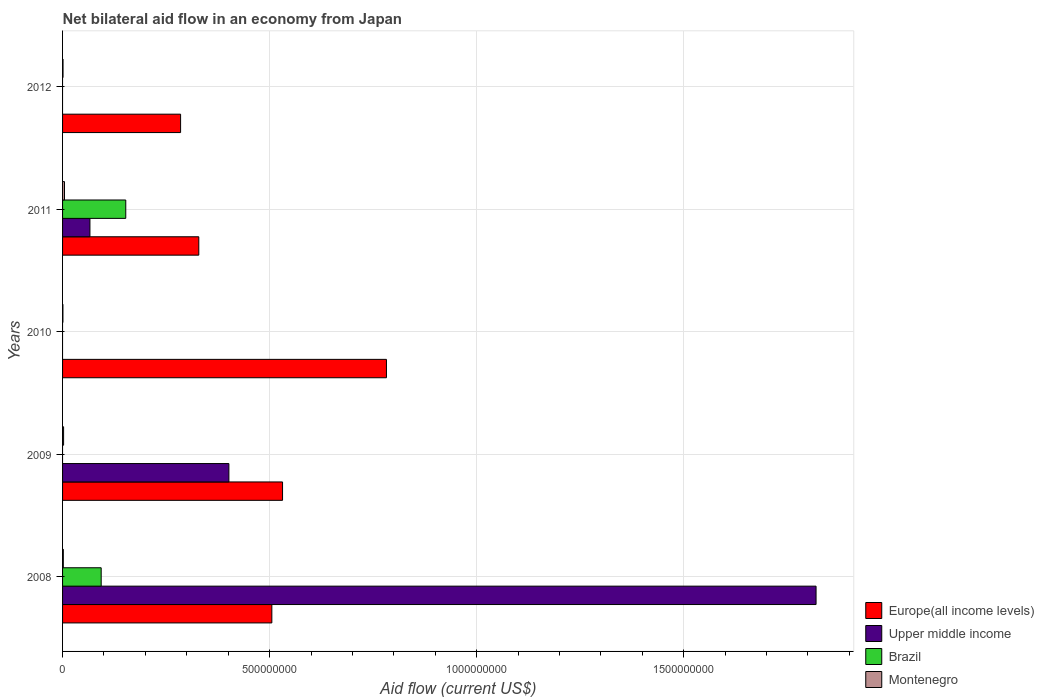How many different coloured bars are there?
Offer a terse response. 4. How many groups of bars are there?
Your response must be concise. 5. Are the number of bars on each tick of the Y-axis equal?
Your answer should be very brief. No. How many bars are there on the 5th tick from the top?
Your answer should be compact. 4. How many bars are there on the 4th tick from the bottom?
Your response must be concise. 4. In how many cases, is the number of bars for a given year not equal to the number of legend labels?
Ensure brevity in your answer.  3. What is the net bilateral aid flow in Brazil in 2012?
Keep it short and to the point. 0. Across all years, what is the maximum net bilateral aid flow in Montenegro?
Make the answer very short. 4.67e+06. Across all years, what is the minimum net bilateral aid flow in Europe(all income levels)?
Offer a terse response. 2.85e+08. In which year was the net bilateral aid flow in Upper middle income maximum?
Your response must be concise. 2008. What is the total net bilateral aid flow in Brazil in the graph?
Your answer should be very brief. 2.46e+08. What is the difference between the net bilateral aid flow in Montenegro in 2009 and that in 2010?
Your answer should be compact. 1.63e+06. What is the difference between the net bilateral aid flow in Brazil in 2010 and the net bilateral aid flow in Europe(all income levels) in 2009?
Your answer should be very brief. -5.31e+08. What is the average net bilateral aid flow in Upper middle income per year?
Provide a short and direct response. 4.58e+08. In the year 2012, what is the difference between the net bilateral aid flow in Montenegro and net bilateral aid flow in Europe(all income levels)?
Offer a terse response. -2.84e+08. What is the ratio of the net bilateral aid flow in Montenegro in 2011 to that in 2012?
Keep it short and to the point. 4.1. Is the difference between the net bilateral aid flow in Montenegro in 2008 and 2009 greater than the difference between the net bilateral aid flow in Europe(all income levels) in 2008 and 2009?
Provide a short and direct response. Yes. What is the difference between the highest and the second highest net bilateral aid flow in Montenegro?
Provide a succinct answer. 2.17e+06. What is the difference between the highest and the lowest net bilateral aid flow in Montenegro?
Your answer should be very brief. 3.80e+06. In how many years, is the net bilateral aid flow in Brazil greater than the average net bilateral aid flow in Brazil taken over all years?
Your response must be concise. 2. Is it the case that in every year, the sum of the net bilateral aid flow in Brazil and net bilateral aid flow in Montenegro is greater than the sum of net bilateral aid flow in Europe(all income levels) and net bilateral aid flow in Upper middle income?
Make the answer very short. No. How many bars are there?
Your answer should be very brief. 15. Are all the bars in the graph horizontal?
Your response must be concise. Yes. What is the difference between two consecutive major ticks on the X-axis?
Your response must be concise. 5.00e+08. Are the values on the major ticks of X-axis written in scientific E-notation?
Provide a succinct answer. No. Does the graph contain any zero values?
Ensure brevity in your answer.  Yes. Where does the legend appear in the graph?
Offer a terse response. Bottom right. How many legend labels are there?
Provide a succinct answer. 4. How are the legend labels stacked?
Your response must be concise. Vertical. What is the title of the graph?
Give a very brief answer. Net bilateral aid flow in an economy from Japan. What is the label or title of the X-axis?
Provide a short and direct response. Aid flow (current US$). What is the label or title of the Y-axis?
Keep it short and to the point. Years. What is the Aid flow (current US$) of Europe(all income levels) in 2008?
Provide a succinct answer. 5.05e+08. What is the Aid flow (current US$) in Upper middle income in 2008?
Provide a short and direct response. 1.82e+09. What is the Aid flow (current US$) in Brazil in 2008?
Your response must be concise. 9.33e+07. What is the Aid flow (current US$) of Montenegro in 2008?
Offer a terse response. 1.85e+06. What is the Aid flow (current US$) of Europe(all income levels) in 2009?
Give a very brief answer. 5.31e+08. What is the Aid flow (current US$) of Upper middle income in 2009?
Offer a very short reply. 4.02e+08. What is the Aid flow (current US$) of Brazil in 2009?
Your answer should be compact. 0. What is the Aid flow (current US$) in Montenegro in 2009?
Your answer should be compact. 2.50e+06. What is the Aid flow (current US$) in Europe(all income levels) in 2010?
Keep it short and to the point. 7.82e+08. What is the Aid flow (current US$) in Montenegro in 2010?
Keep it short and to the point. 8.70e+05. What is the Aid flow (current US$) in Europe(all income levels) in 2011?
Ensure brevity in your answer.  3.29e+08. What is the Aid flow (current US$) in Upper middle income in 2011?
Give a very brief answer. 6.61e+07. What is the Aid flow (current US$) of Brazil in 2011?
Provide a succinct answer. 1.53e+08. What is the Aid flow (current US$) of Montenegro in 2011?
Ensure brevity in your answer.  4.67e+06. What is the Aid flow (current US$) in Europe(all income levels) in 2012?
Your response must be concise. 2.85e+08. What is the Aid flow (current US$) in Upper middle income in 2012?
Keep it short and to the point. 0. What is the Aid flow (current US$) of Montenegro in 2012?
Keep it short and to the point. 1.14e+06. Across all years, what is the maximum Aid flow (current US$) of Europe(all income levels)?
Provide a short and direct response. 7.82e+08. Across all years, what is the maximum Aid flow (current US$) of Upper middle income?
Your answer should be very brief. 1.82e+09. Across all years, what is the maximum Aid flow (current US$) of Brazil?
Provide a succinct answer. 1.53e+08. Across all years, what is the maximum Aid flow (current US$) in Montenegro?
Offer a very short reply. 4.67e+06. Across all years, what is the minimum Aid flow (current US$) in Europe(all income levels)?
Provide a succinct answer. 2.85e+08. Across all years, what is the minimum Aid flow (current US$) in Upper middle income?
Your answer should be compact. 0. Across all years, what is the minimum Aid flow (current US$) of Montenegro?
Offer a very short reply. 8.70e+05. What is the total Aid flow (current US$) in Europe(all income levels) in the graph?
Provide a succinct answer. 2.43e+09. What is the total Aid flow (current US$) of Upper middle income in the graph?
Provide a succinct answer. 2.29e+09. What is the total Aid flow (current US$) of Brazil in the graph?
Offer a very short reply. 2.46e+08. What is the total Aid flow (current US$) of Montenegro in the graph?
Provide a succinct answer. 1.10e+07. What is the difference between the Aid flow (current US$) of Europe(all income levels) in 2008 and that in 2009?
Your answer should be compact. -2.58e+07. What is the difference between the Aid flow (current US$) in Upper middle income in 2008 and that in 2009?
Your answer should be compact. 1.42e+09. What is the difference between the Aid flow (current US$) of Montenegro in 2008 and that in 2009?
Keep it short and to the point. -6.50e+05. What is the difference between the Aid flow (current US$) in Europe(all income levels) in 2008 and that in 2010?
Keep it short and to the point. -2.77e+08. What is the difference between the Aid flow (current US$) of Montenegro in 2008 and that in 2010?
Offer a very short reply. 9.80e+05. What is the difference between the Aid flow (current US$) in Europe(all income levels) in 2008 and that in 2011?
Offer a terse response. 1.76e+08. What is the difference between the Aid flow (current US$) in Upper middle income in 2008 and that in 2011?
Provide a short and direct response. 1.75e+09. What is the difference between the Aid flow (current US$) of Brazil in 2008 and that in 2011?
Your response must be concise. -5.94e+07. What is the difference between the Aid flow (current US$) in Montenegro in 2008 and that in 2011?
Your answer should be compact. -2.82e+06. What is the difference between the Aid flow (current US$) of Europe(all income levels) in 2008 and that in 2012?
Your response must be concise. 2.20e+08. What is the difference between the Aid flow (current US$) of Montenegro in 2008 and that in 2012?
Offer a terse response. 7.10e+05. What is the difference between the Aid flow (current US$) of Europe(all income levels) in 2009 and that in 2010?
Offer a very short reply. -2.51e+08. What is the difference between the Aid flow (current US$) in Montenegro in 2009 and that in 2010?
Your answer should be very brief. 1.63e+06. What is the difference between the Aid flow (current US$) in Europe(all income levels) in 2009 and that in 2011?
Give a very brief answer. 2.02e+08. What is the difference between the Aid flow (current US$) of Upper middle income in 2009 and that in 2011?
Offer a very short reply. 3.36e+08. What is the difference between the Aid flow (current US$) of Montenegro in 2009 and that in 2011?
Ensure brevity in your answer.  -2.17e+06. What is the difference between the Aid flow (current US$) in Europe(all income levels) in 2009 and that in 2012?
Offer a terse response. 2.46e+08. What is the difference between the Aid flow (current US$) of Montenegro in 2009 and that in 2012?
Offer a terse response. 1.36e+06. What is the difference between the Aid flow (current US$) in Europe(all income levels) in 2010 and that in 2011?
Make the answer very short. 4.53e+08. What is the difference between the Aid flow (current US$) in Montenegro in 2010 and that in 2011?
Your response must be concise. -3.80e+06. What is the difference between the Aid flow (current US$) of Europe(all income levels) in 2010 and that in 2012?
Your answer should be very brief. 4.97e+08. What is the difference between the Aid flow (current US$) in Montenegro in 2010 and that in 2012?
Offer a terse response. -2.70e+05. What is the difference between the Aid flow (current US$) in Europe(all income levels) in 2011 and that in 2012?
Give a very brief answer. 4.40e+07. What is the difference between the Aid flow (current US$) in Montenegro in 2011 and that in 2012?
Offer a very short reply. 3.53e+06. What is the difference between the Aid flow (current US$) of Europe(all income levels) in 2008 and the Aid flow (current US$) of Upper middle income in 2009?
Provide a succinct answer. 1.04e+08. What is the difference between the Aid flow (current US$) of Europe(all income levels) in 2008 and the Aid flow (current US$) of Montenegro in 2009?
Give a very brief answer. 5.03e+08. What is the difference between the Aid flow (current US$) of Upper middle income in 2008 and the Aid flow (current US$) of Montenegro in 2009?
Your response must be concise. 1.82e+09. What is the difference between the Aid flow (current US$) of Brazil in 2008 and the Aid flow (current US$) of Montenegro in 2009?
Provide a short and direct response. 9.08e+07. What is the difference between the Aid flow (current US$) of Europe(all income levels) in 2008 and the Aid flow (current US$) of Montenegro in 2010?
Give a very brief answer. 5.05e+08. What is the difference between the Aid flow (current US$) of Upper middle income in 2008 and the Aid flow (current US$) of Montenegro in 2010?
Provide a succinct answer. 1.82e+09. What is the difference between the Aid flow (current US$) of Brazil in 2008 and the Aid flow (current US$) of Montenegro in 2010?
Give a very brief answer. 9.24e+07. What is the difference between the Aid flow (current US$) in Europe(all income levels) in 2008 and the Aid flow (current US$) in Upper middle income in 2011?
Your answer should be very brief. 4.39e+08. What is the difference between the Aid flow (current US$) of Europe(all income levels) in 2008 and the Aid flow (current US$) of Brazil in 2011?
Your answer should be compact. 3.53e+08. What is the difference between the Aid flow (current US$) of Europe(all income levels) in 2008 and the Aid flow (current US$) of Montenegro in 2011?
Offer a very short reply. 5.01e+08. What is the difference between the Aid flow (current US$) in Upper middle income in 2008 and the Aid flow (current US$) in Brazil in 2011?
Provide a short and direct response. 1.67e+09. What is the difference between the Aid flow (current US$) in Upper middle income in 2008 and the Aid flow (current US$) in Montenegro in 2011?
Provide a succinct answer. 1.82e+09. What is the difference between the Aid flow (current US$) in Brazil in 2008 and the Aid flow (current US$) in Montenegro in 2011?
Offer a terse response. 8.86e+07. What is the difference between the Aid flow (current US$) in Europe(all income levels) in 2008 and the Aid flow (current US$) in Montenegro in 2012?
Make the answer very short. 5.04e+08. What is the difference between the Aid flow (current US$) of Upper middle income in 2008 and the Aid flow (current US$) of Montenegro in 2012?
Provide a short and direct response. 1.82e+09. What is the difference between the Aid flow (current US$) in Brazil in 2008 and the Aid flow (current US$) in Montenegro in 2012?
Your answer should be very brief. 9.21e+07. What is the difference between the Aid flow (current US$) in Europe(all income levels) in 2009 and the Aid flow (current US$) in Montenegro in 2010?
Provide a short and direct response. 5.30e+08. What is the difference between the Aid flow (current US$) of Upper middle income in 2009 and the Aid flow (current US$) of Montenegro in 2010?
Your answer should be very brief. 4.01e+08. What is the difference between the Aid flow (current US$) of Europe(all income levels) in 2009 and the Aid flow (current US$) of Upper middle income in 2011?
Offer a very short reply. 4.65e+08. What is the difference between the Aid flow (current US$) of Europe(all income levels) in 2009 and the Aid flow (current US$) of Brazil in 2011?
Give a very brief answer. 3.79e+08. What is the difference between the Aid flow (current US$) of Europe(all income levels) in 2009 and the Aid flow (current US$) of Montenegro in 2011?
Keep it short and to the point. 5.27e+08. What is the difference between the Aid flow (current US$) of Upper middle income in 2009 and the Aid flow (current US$) of Brazil in 2011?
Your answer should be very brief. 2.49e+08. What is the difference between the Aid flow (current US$) in Upper middle income in 2009 and the Aid flow (current US$) in Montenegro in 2011?
Ensure brevity in your answer.  3.97e+08. What is the difference between the Aid flow (current US$) of Europe(all income levels) in 2009 and the Aid flow (current US$) of Montenegro in 2012?
Offer a very short reply. 5.30e+08. What is the difference between the Aid flow (current US$) in Upper middle income in 2009 and the Aid flow (current US$) in Montenegro in 2012?
Offer a very short reply. 4.01e+08. What is the difference between the Aid flow (current US$) of Europe(all income levels) in 2010 and the Aid flow (current US$) of Upper middle income in 2011?
Provide a short and direct response. 7.16e+08. What is the difference between the Aid flow (current US$) of Europe(all income levels) in 2010 and the Aid flow (current US$) of Brazil in 2011?
Provide a succinct answer. 6.30e+08. What is the difference between the Aid flow (current US$) in Europe(all income levels) in 2010 and the Aid flow (current US$) in Montenegro in 2011?
Ensure brevity in your answer.  7.78e+08. What is the difference between the Aid flow (current US$) in Europe(all income levels) in 2010 and the Aid flow (current US$) in Montenegro in 2012?
Offer a very short reply. 7.81e+08. What is the difference between the Aid flow (current US$) of Europe(all income levels) in 2011 and the Aid flow (current US$) of Montenegro in 2012?
Provide a short and direct response. 3.28e+08. What is the difference between the Aid flow (current US$) in Upper middle income in 2011 and the Aid flow (current US$) in Montenegro in 2012?
Offer a very short reply. 6.50e+07. What is the difference between the Aid flow (current US$) of Brazil in 2011 and the Aid flow (current US$) of Montenegro in 2012?
Offer a terse response. 1.51e+08. What is the average Aid flow (current US$) in Europe(all income levels) per year?
Offer a very short reply. 4.87e+08. What is the average Aid flow (current US$) of Upper middle income per year?
Offer a terse response. 4.58e+08. What is the average Aid flow (current US$) in Brazil per year?
Give a very brief answer. 4.92e+07. What is the average Aid flow (current US$) of Montenegro per year?
Provide a succinct answer. 2.21e+06. In the year 2008, what is the difference between the Aid flow (current US$) in Europe(all income levels) and Aid flow (current US$) in Upper middle income?
Provide a short and direct response. -1.31e+09. In the year 2008, what is the difference between the Aid flow (current US$) of Europe(all income levels) and Aid flow (current US$) of Brazil?
Keep it short and to the point. 4.12e+08. In the year 2008, what is the difference between the Aid flow (current US$) of Europe(all income levels) and Aid flow (current US$) of Montenegro?
Offer a very short reply. 5.04e+08. In the year 2008, what is the difference between the Aid flow (current US$) of Upper middle income and Aid flow (current US$) of Brazil?
Make the answer very short. 1.73e+09. In the year 2008, what is the difference between the Aid flow (current US$) in Upper middle income and Aid flow (current US$) in Montenegro?
Make the answer very short. 1.82e+09. In the year 2008, what is the difference between the Aid flow (current US$) of Brazil and Aid flow (current US$) of Montenegro?
Make the answer very short. 9.14e+07. In the year 2009, what is the difference between the Aid flow (current US$) in Europe(all income levels) and Aid flow (current US$) in Upper middle income?
Make the answer very short. 1.30e+08. In the year 2009, what is the difference between the Aid flow (current US$) of Europe(all income levels) and Aid flow (current US$) of Montenegro?
Offer a terse response. 5.29e+08. In the year 2009, what is the difference between the Aid flow (current US$) in Upper middle income and Aid flow (current US$) in Montenegro?
Provide a succinct answer. 3.99e+08. In the year 2010, what is the difference between the Aid flow (current US$) in Europe(all income levels) and Aid flow (current US$) in Montenegro?
Your answer should be compact. 7.81e+08. In the year 2011, what is the difference between the Aid flow (current US$) in Europe(all income levels) and Aid flow (current US$) in Upper middle income?
Provide a short and direct response. 2.63e+08. In the year 2011, what is the difference between the Aid flow (current US$) of Europe(all income levels) and Aid flow (current US$) of Brazil?
Ensure brevity in your answer.  1.76e+08. In the year 2011, what is the difference between the Aid flow (current US$) of Europe(all income levels) and Aid flow (current US$) of Montenegro?
Your answer should be very brief. 3.24e+08. In the year 2011, what is the difference between the Aid flow (current US$) in Upper middle income and Aid flow (current US$) in Brazil?
Make the answer very short. -8.65e+07. In the year 2011, what is the difference between the Aid flow (current US$) of Upper middle income and Aid flow (current US$) of Montenegro?
Make the answer very short. 6.14e+07. In the year 2011, what is the difference between the Aid flow (current US$) in Brazil and Aid flow (current US$) in Montenegro?
Provide a short and direct response. 1.48e+08. In the year 2012, what is the difference between the Aid flow (current US$) of Europe(all income levels) and Aid flow (current US$) of Montenegro?
Make the answer very short. 2.84e+08. What is the ratio of the Aid flow (current US$) in Europe(all income levels) in 2008 to that in 2009?
Offer a very short reply. 0.95. What is the ratio of the Aid flow (current US$) of Upper middle income in 2008 to that in 2009?
Make the answer very short. 4.53. What is the ratio of the Aid flow (current US$) in Montenegro in 2008 to that in 2009?
Your response must be concise. 0.74. What is the ratio of the Aid flow (current US$) of Europe(all income levels) in 2008 to that in 2010?
Keep it short and to the point. 0.65. What is the ratio of the Aid flow (current US$) of Montenegro in 2008 to that in 2010?
Provide a short and direct response. 2.13. What is the ratio of the Aid flow (current US$) of Europe(all income levels) in 2008 to that in 2011?
Provide a short and direct response. 1.54. What is the ratio of the Aid flow (current US$) of Upper middle income in 2008 to that in 2011?
Your answer should be very brief. 27.53. What is the ratio of the Aid flow (current US$) of Brazil in 2008 to that in 2011?
Provide a short and direct response. 0.61. What is the ratio of the Aid flow (current US$) in Montenegro in 2008 to that in 2011?
Provide a succinct answer. 0.4. What is the ratio of the Aid flow (current US$) of Europe(all income levels) in 2008 to that in 2012?
Ensure brevity in your answer.  1.77. What is the ratio of the Aid flow (current US$) in Montenegro in 2008 to that in 2012?
Give a very brief answer. 1.62. What is the ratio of the Aid flow (current US$) in Europe(all income levels) in 2009 to that in 2010?
Make the answer very short. 0.68. What is the ratio of the Aid flow (current US$) in Montenegro in 2009 to that in 2010?
Provide a succinct answer. 2.87. What is the ratio of the Aid flow (current US$) in Europe(all income levels) in 2009 to that in 2011?
Your answer should be compact. 1.61. What is the ratio of the Aid flow (current US$) in Upper middle income in 2009 to that in 2011?
Ensure brevity in your answer.  6.08. What is the ratio of the Aid flow (current US$) of Montenegro in 2009 to that in 2011?
Make the answer very short. 0.54. What is the ratio of the Aid flow (current US$) in Europe(all income levels) in 2009 to that in 2012?
Keep it short and to the point. 1.86. What is the ratio of the Aid flow (current US$) in Montenegro in 2009 to that in 2012?
Provide a succinct answer. 2.19. What is the ratio of the Aid flow (current US$) of Europe(all income levels) in 2010 to that in 2011?
Ensure brevity in your answer.  2.38. What is the ratio of the Aid flow (current US$) in Montenegro in 2010 to that in 2011?
Make the answer very short. 0.19. What is the ratio of the Aid flow (current US$) in Europe(all income levels) in 2010 to that in 2012?
Your answer should be very brief. 2.74. What is the ratio of the Aid flow (current US$) of Montenegro in 2010 to that in 2012?
Provide a short and direct response. 0.76. What is the ratio of the Aid flow (current US$) in Europe(all income levels) in 2011 to that in 2012?
Ensure brevity in your answer.  1.15. What is the ratio of the Aid flow (current US$) in Montenegro in 2011 to that in 2012?
Keep it short and to the point. 4.1. What is the difference between the highest and the second highest Aid flow (current US$) of Europe(all income levels)?
Keep it short and to the point. 2.51e+08. What is the difference between the highest and the second highest Aid flow (current US$) of Upper middle income?
Offer a very short reply. 1.42e+09. What is the difference between the highest and the second highest Aid flow (current US$) in Montenegro?
Keep it short and to the point. 2.17e+06. What is the difference between the highest and the lowest Aid flow (current US$) of Europe(all income levels)?
Ensure brevity in your answer.  4.97e+08. What is the difference between the highest and the lowest Aid flow (current US$) in Upper middle income?
Your answer should be very brief. 1.82e+09. What is the difference between the highest and the lowest Aid flow (current US$) of Brazil?
Your answer should be compact. 1.53e+08. What is the difference between the highest and the lowest Aid flow (current US$) in Montenegro?
Your response must be concise. 3.80e+06. 